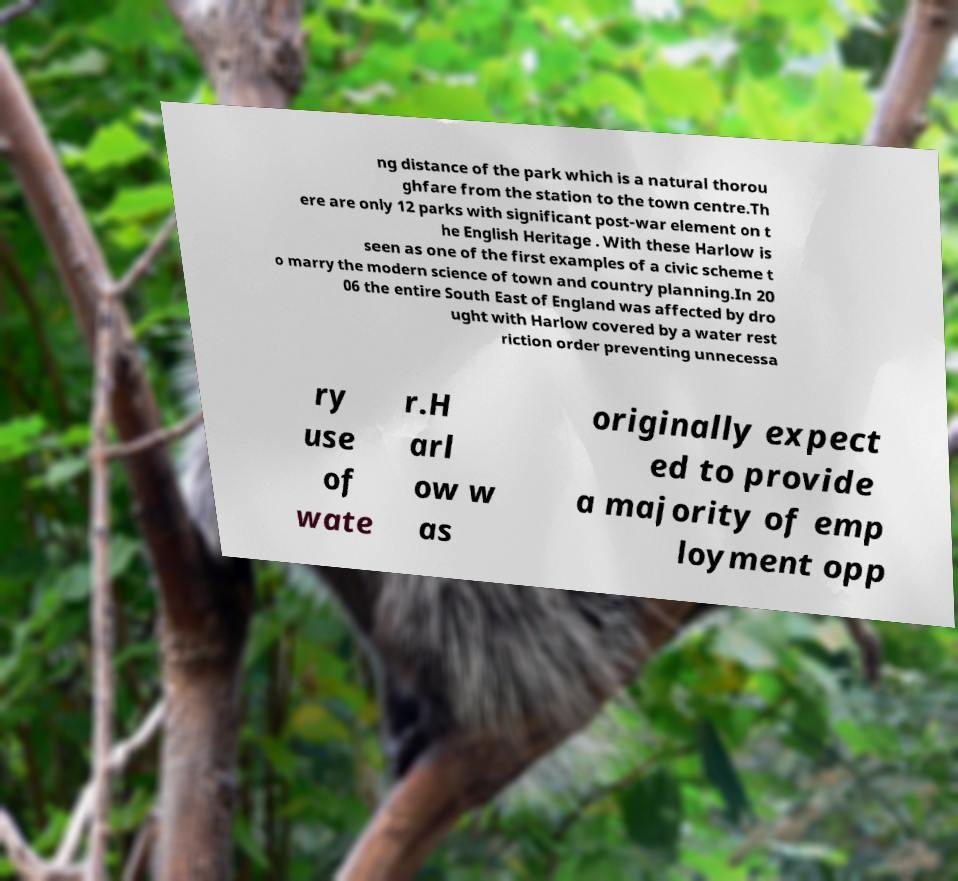Can you accurately transcribe the text from the provided image for me? ng distance of the park which is a natural thorou ghfare from the station to the town centre.Th ere are only 12 parks with significant post-war element on t he English Heritage . With these Harlow is seen as one of the first examples of a civic scheme t o marry the modern science of town and country planning.In 20 06 the entire South East of England was affected by dro ught with Harlow covered by a water rest riction order preventing unnecessa ry use of wate r.H arl ow w as originally expect ed to provide a majority of emp loyment opp 